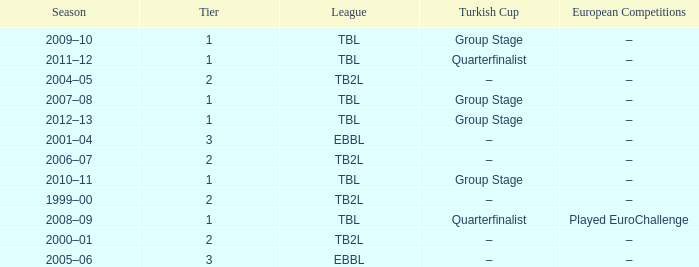Tier of 2, and a Season of 2000–01 is what European competitions? –. 